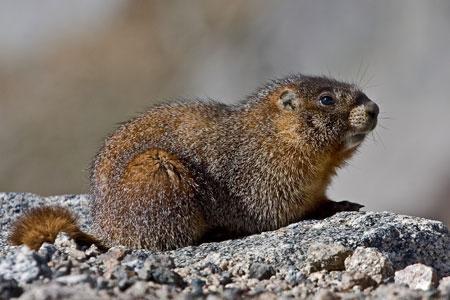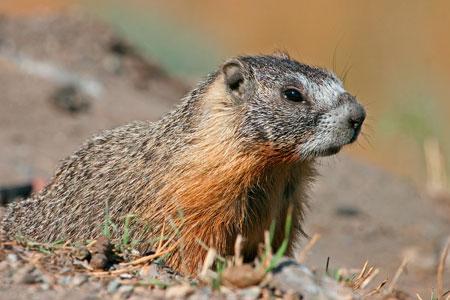The first image is the image on the left, the second image is the image on the right. Considering the images on both sides, is "There are three animals near the rocks." valid? Answer yes or no. No. 